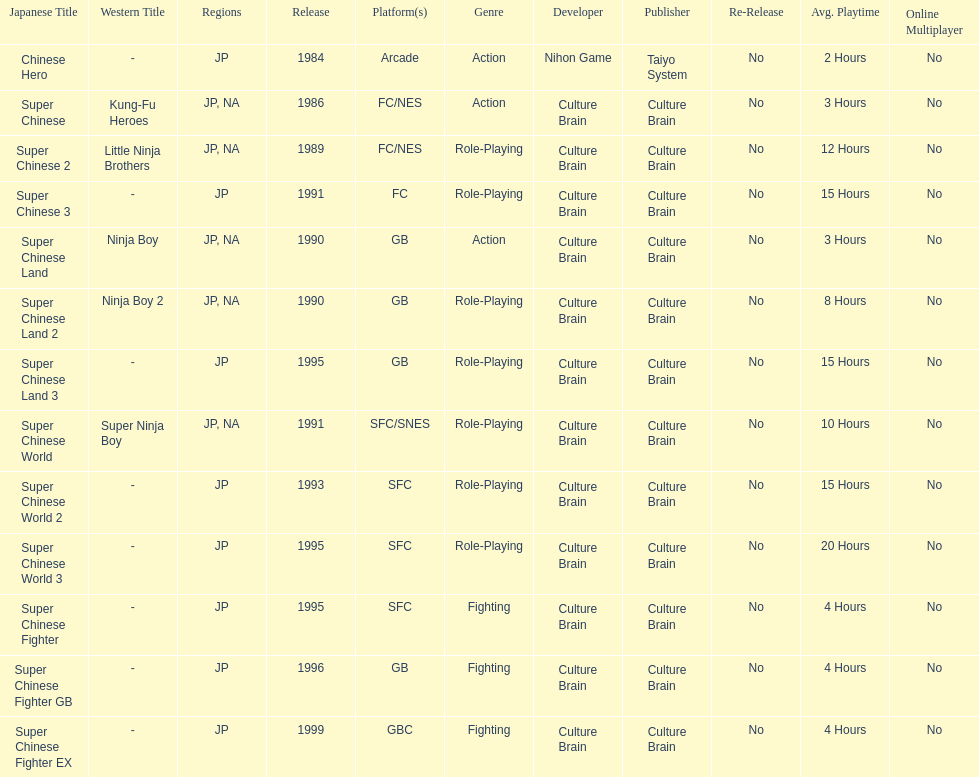Number of super chinese world games released 3. 